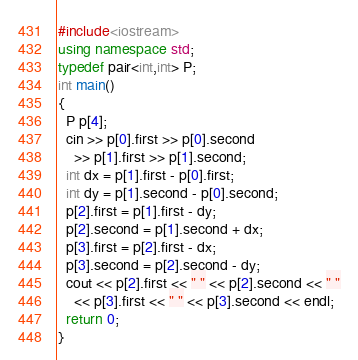<code> <loc_0><loc_0><loc_500><loc_500><_C++_>#include<iostream>
using namespace std;
typedef pair<int,int> P;
int main()
{
  P p[4];
  cin >> p[0].first >> p[0].second
    >> p[1].first >> p[1].second;
  int dx = p[1].first - p[0].first;
  int dy = p[1].second - p[0].second;
  p[2].first = p[1].first - dy;
  p[2].second = p[1].second + dx;
  p[3].first = p[2].first - dx;
  p[3].second = p[2].second - dy;
  cout << p[2].first << " " << p[2].second << " "
    << p[3].first << " " << p[3].second << endl;
  return 0;
}</code> 